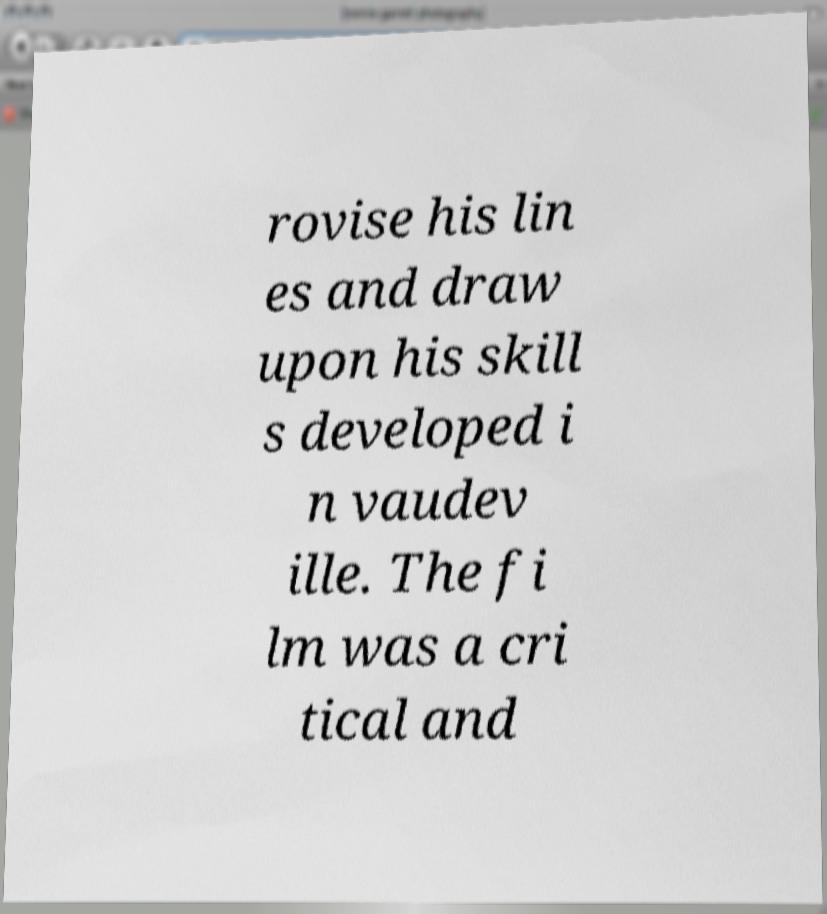Can you accurately transcribe the text from the provided image for me? rovise his lin es and draw upon his skill s developed i n vaudev ille. The fi lm was a cri tical and 